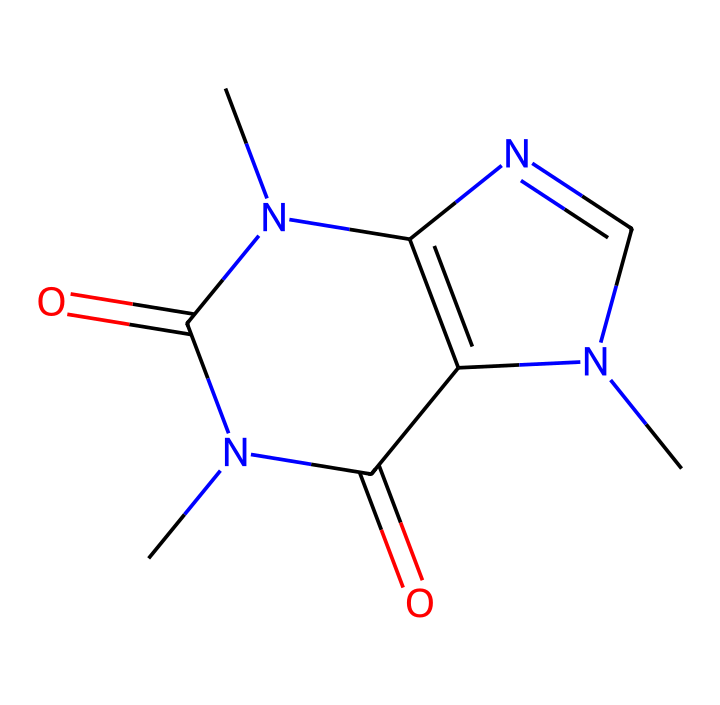What is the molecular formula of caffeine? To determine the molecular formula, we identify the numbers of carbon (C), hydrogen (H), nitrogen (N), and oxygen (O) atoms present in the structure. The structure shows 8 carbons, 10 hydrogens, 4 nitrogens, and 2 oxygens, giving the formula C8H10N4O2.
Answer: C8H10N4O2 How many nitrogen atoms are in caffeine? By examining the structure, we count the nitrogen (N) atoms present. There are four distinct nitrogen atoms indicated in the chemical structure.
Answer: 4 What type of compounds does caffeine belong to? Caffeine is categorized as an alkaloid due to the presence of nitrogen and its physiological effects. Alkaloids typically have a basic structure and exhibit effects on the nervous system.
Answer: alkaloid What is the primary functional group in caffeine? Evaluating the structure, we recognize the presence of carbonyl groups (C=O), which are characteristic functional groups in amides. Consequently, caffeine contains amide functional groups.
Answer: amide Can caffeine conduct electricity in solution? Caffeine is classified as a non-electrolyte, which means it does not dissociate into ions when dissolved in water and, therefore, does not conduct electricity.
Answer: no What is the likely taste of caffeine based on its structure? The structure contains nitrogen atoms and is classified as an alkaloid, which commonly confers a bitter taste to many compounds, including caffeine.
Answer: bitter 